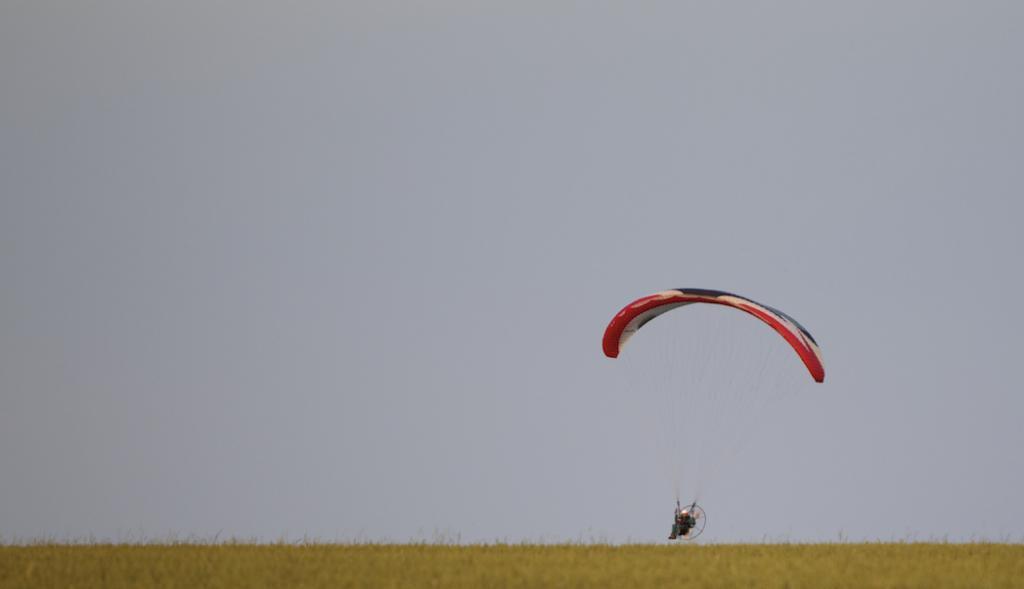Please provide a concise description of this image. In this picture we can see a cloudy sky and a person Paragliding. We can see the grass on the ground. 